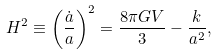<formula> <loc_0><loc_0><loc_500><loc_500>H ^ { 2 } \equiv \left ( \frac { \dot { a } } { a } \right ) ^ { 2 } = \frac { 8 \pi G V } { 3 } - \frac { k } { a ^ { 2 } } ,</formula> 